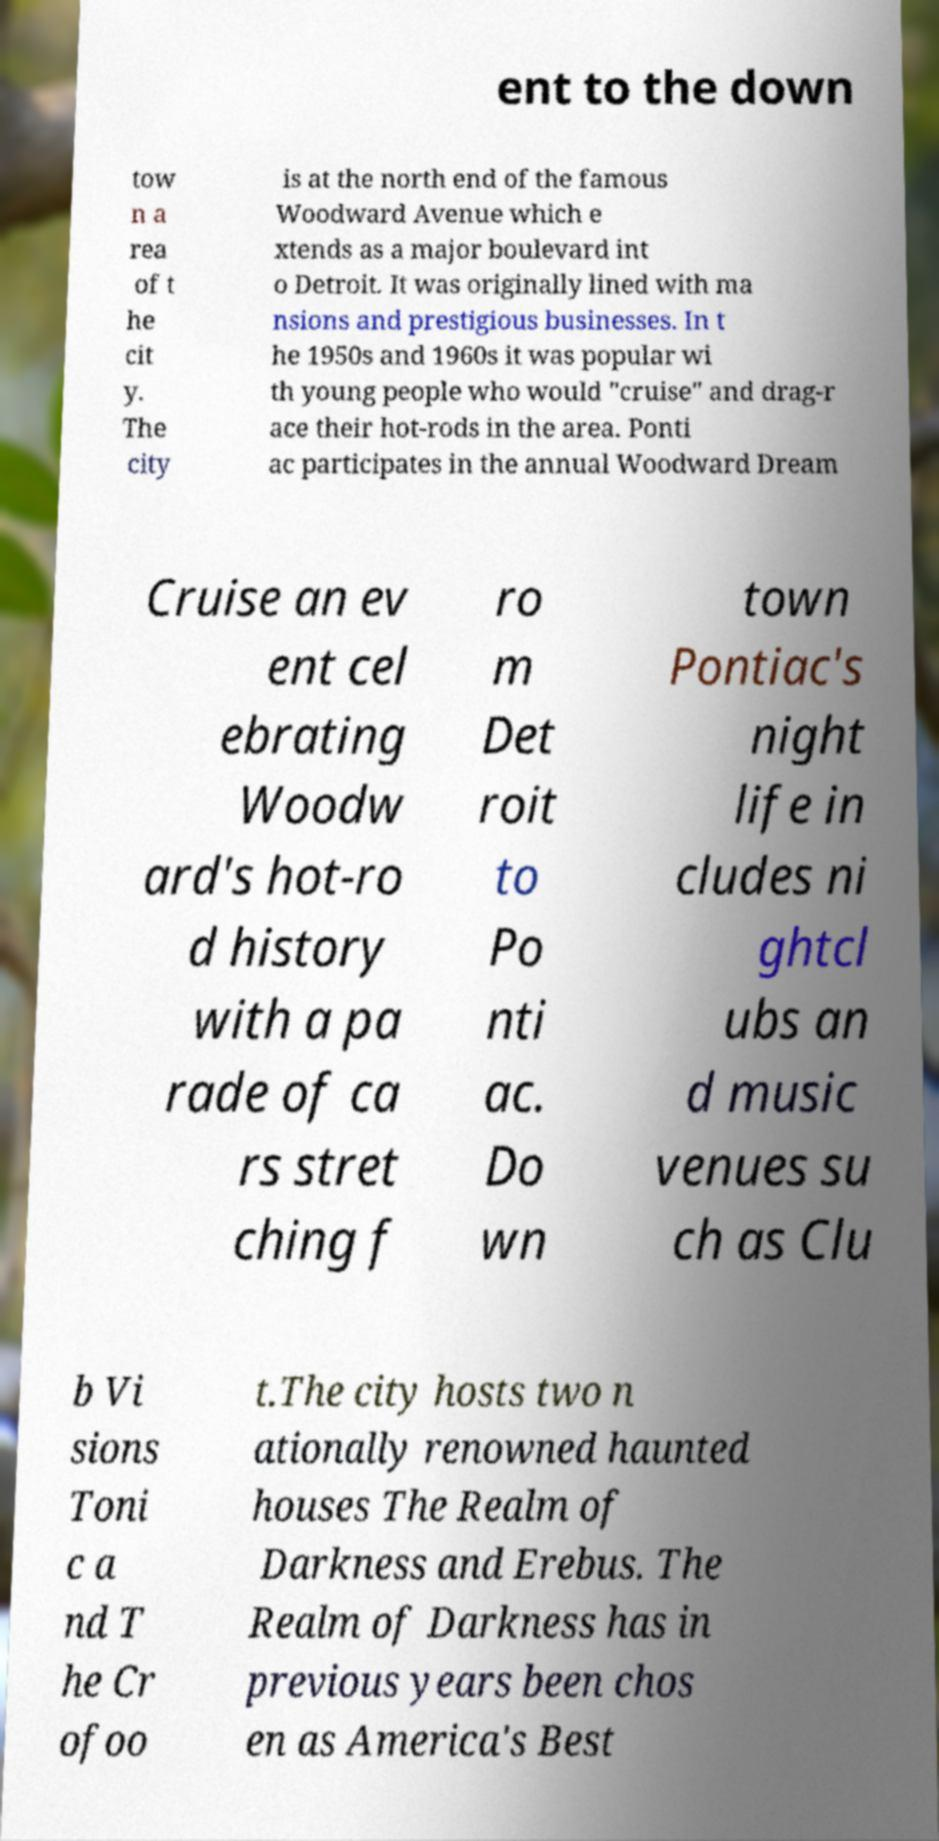Could you assist in decoding the text presented in this image and type it out clearly? ent to the down tow n a rea of t he cit y. The city is at the north end of the famous Woodward Avenue which e xtends as a major boulevard int o Detroit. It was originally lined with ma nsions and prestigious businesses. In t he 1950s and 1960s it was popular wi th young people who would "cruise" and drag-r ace their hot-rods in the area. Ponti ac participates in the annual Woodward Dream Cruise an ev ent cel ebrating Woodw ard's hot-ro d history with a pa rade of ca rs stret ching f ro m Det roit to Po nti ac. Do wn town Pontiac's night life in cludes ni ghtcl ubs an d music venues su ch as Clu b Vi sions Toni c a nd T he Cr ofoo t.The city hosts two n ationally renowned haunted houses The Realm of Darkness and Erebus. The Realm of Darkness has in previous years been chos en as America's Best 